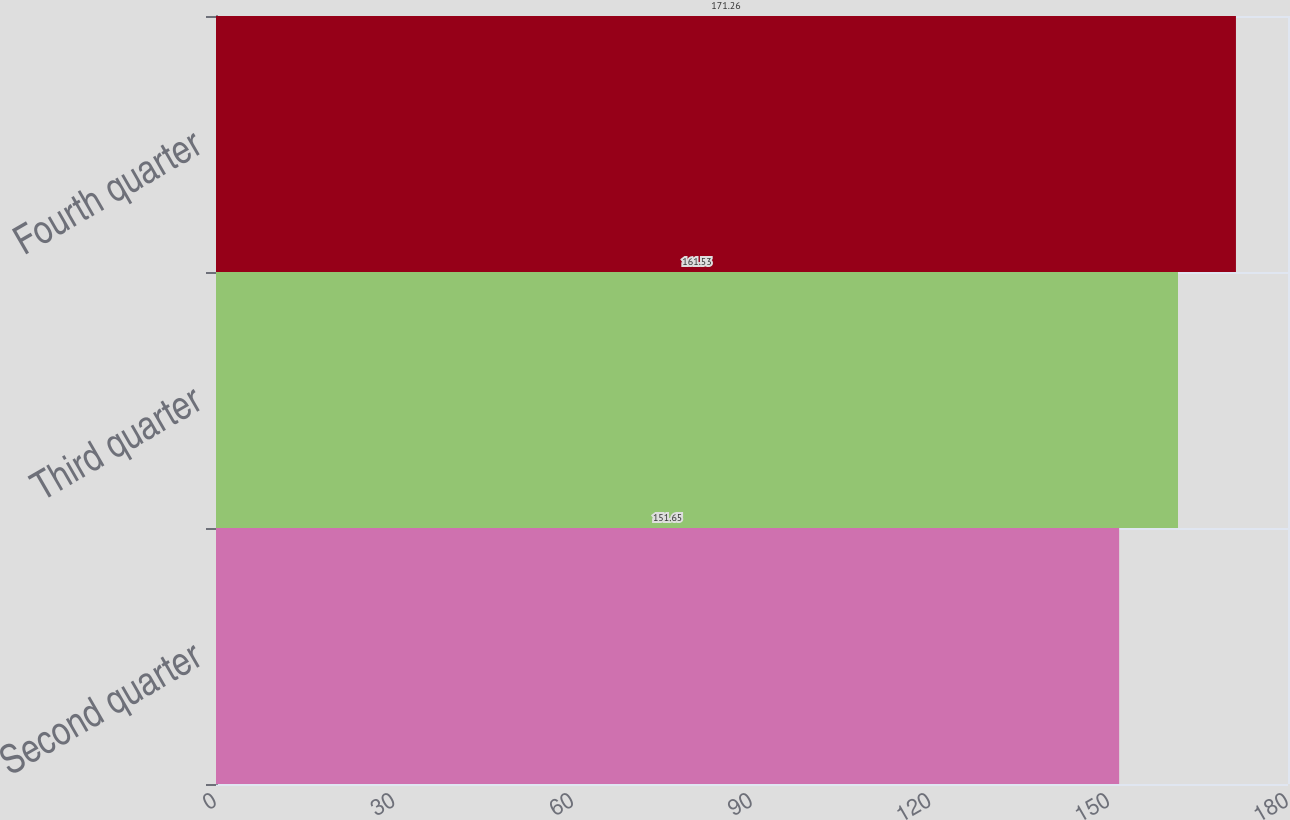Convert chart. <chart><loc_0><loc_0><loc_500><loc_500><bar_chart><fcel>Second quarter<fcel>Third quarter<fcel>Fourth quarter<nl><fcel>151.65<fcel>161.53<fcel>171.26<nl></chart> 